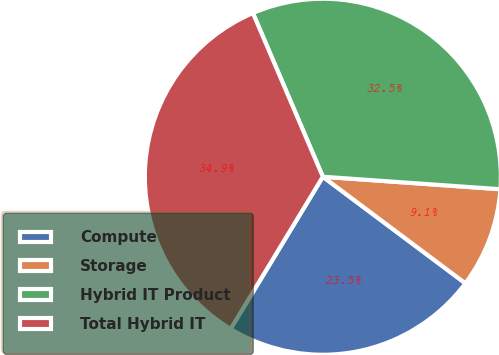<chart> <loc_0><loc_0><loc_500><loc_500><pie_chart><fcel>Compute<fcel>Storage<fcel>Hybrid IT Product<fcel>Total Hybrid IT<nl><fcel>23.46%<fcel>9.1%<fcel>32.55%<fcel>34.9%<nl></chart> 